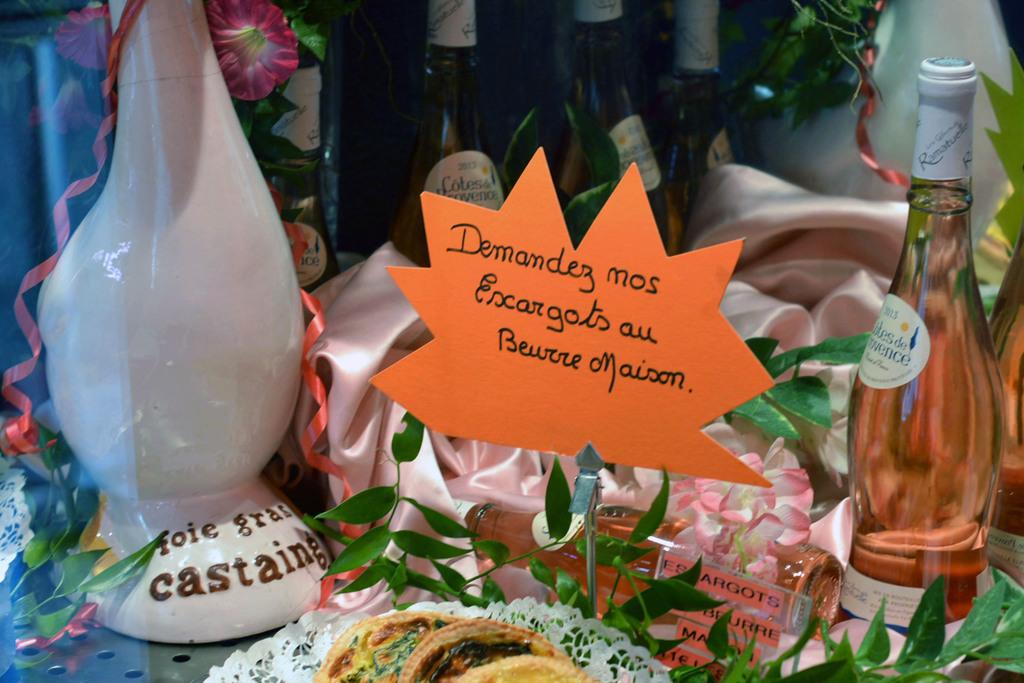What does the orange leaf say?
Your response must be concise. Unanswerable. What is written on the white container on the left?
Ensure brevity in your answer.  Foie gras castaing. 